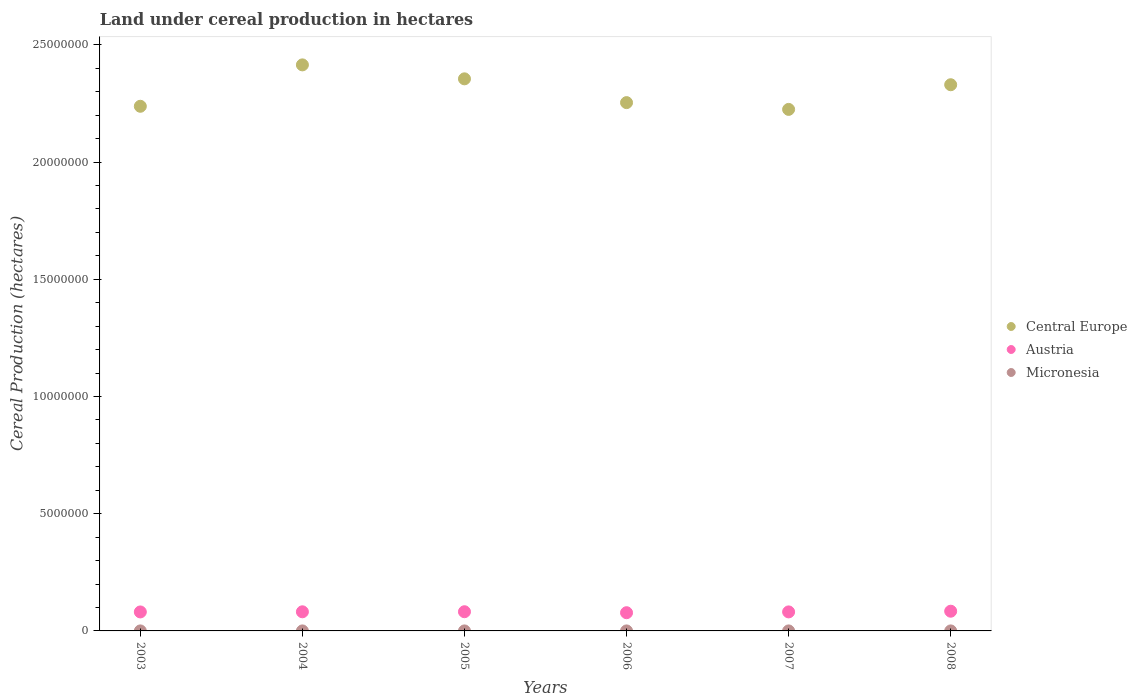What is the land under cereal production in Central Europe in 2007?
Provide a succinct answer. 2.22e+07. Across all years, what is the maximum land under cereal production in Austria?
Offer a terse response. 8.41e+05. Across all years, what is the minimum land under cereal production in Micronesia?
Offer a terse response. 140. In which year was the land under cereal production in Micronesia maximum?
Offer a terse response. 2004. In which year was the land under cereal production in Central Europe minimum?
Ensure brevity in your answer.  2007. What is the total land under cereal production in Austria in the graph?
Offer a terse response. 4.87e+06. What is the difference between the land under cereal production in Austria in 2004 and that in 2005?
Your answer should be compact. -2790. What is the difference between the land under cereal production in Micronesia in 2004 and the land under cereal production in Austria in 2007?
Make the answer very short. -8.11e+05. What is the average land under cereal production in Micronesia per year?
Offer a terse response. 149.67. In the year 2003, what is the difference between the land under cereal production in Central Europe and land under cereal production in Micronesia?
Your answer should be very brief. 2.24e+07. In how many years, is the land under cereal production in Micronesia greater than 12000000 hectares?
Provide a short and direct response. 0. What is the ratio of the land under cereal production in Austria in 2004 to that in 2006?
Keep it short and to the point. 1.05. Is the difference between the land under cereal production in Central Europe in 2003 and 2008 greater than the difference between the land under cereal production in Micronesia in 2003 and 2008?
Make the answer very short. No. What is the difference between the highest and the lowest land under cereal production in Austria?
Keep it short and to the point. 6.42e+04. Are the values on the major ticks of Y-axis written in scientific E-notation?
Provide a succinct answer. No. Does the graph contain any zero values?
Offer a very short reply. No. Does the graph contain grids?
Offer a very short reply. No. How many legend labels are there?
Your answer should be compact. 3. What is the title of the graph?
Your answer should be compact. Land under cereal production in hectares. Does "Kuwait" appear as one of the legend labels in the graph?
Ensure brevity in your answer.  No. What is the label or title of the X-axis?
Offer a very short reply. Years. What is the label or title of the Y-axis?
Offer a terse response. Cereal Production (hectares). What is the Cereal Production (hectares) of Central Europe in 2003?
Make the answer very short. 2.24e+07. What is the Cereal Production (hectares) in Austria in 2003?
Provide a succinct answer. 8.10e+05. What is the Cereal Production (hectares) in Micronesia in 2003?
Your answer should be very brief. 147. What is the Cereal Production (hectares) of Central Europe in 2004?
Your answer should be compact. 2.41e+07. What is the Cereal Production (hectares) of Austria in 2004?
Provide a succinct answer. 8.16e+05. What is the Cereal Production (hectares) of Micronesia in 2004?
Give a very brief answer. 158. What is the Cereal Production (hectares) in Central Europe in 2005?
Ensure brevity in your answer.  2.36e+07. What is the Cereal Production (hectares) of Austria in 2005?
Make the answer very short. 8.19e+05. What is the Cereal Production (hectares) of Micronesia in 2005?
Keep it short and to the point. 156. What is the Cereal Production (hectares) in Central Europe in 2006?
Provide a short and direct response. 2.25e+07. What is the Cereal Production (hectares) of Austria in 2006?
Provide a succinct answer. 7.77e+05. What is the Cereal Production (hectares) in Micronesia in 2006?
Provide a short and direct response. 154. What is the Cereal Production (hectares) of Central Europe in 2007?
Keep it short and to the point. 2.22e+07. What is the Cereal Production (hectares) in Austria in 2007?
Provide a short and direct response. 8.11e+05. What is the Cereal Production (hectares) in Micronesia in 2007?
Make the answer very short. 140. What is the Cereal Production (hectares) of Central Europe in 2008?
Provide a succinct answer. 2.33e+07. What is the Cereal Production (hectares) in Austria in 2008?
Your answer should be compact. 8.41e+05. What is the Cereal Production (hectares) in Micronesia in 2008?
Offer a very short reply. 143. Across all years, what is the maximum Cereal Production (hectares) in Central Europe?
Keep it short and to the point. 2.41e+07. Across all years, what is the maximum Cereal Production (hectares) in Austria?
Make the answer very short. 8.41e+05. Across all years, what is the maximum Cereal Production (hectares) in Micronesia?
Provide a short and direct response. 158. Across all years, what is the minimum Cereal Production (hectares) of Central Europe?
Give a very brief answer. 2.22e+07. Across all years, what is the minimum Cereal Production (hectares) in Austria?
Make the answer very short. 7.77e+05. Across all years, what is the minimum Cereal Production (hectares) in Micronesia?
Provide a succinct answer. 140. What is the total Cereal Production (hectares) of Central Europe in the graph?
Provide a short and direct response. 1.38e+08. What is the total Cereal Production (hectares) in Austria in the graph?
Ensure brevity in your answer.  4.87e+06. What is the total Cereal Production (hectares) in Micronesia in the graph?
Provide a succinct answer. 898. What is the difference between the Cereal Production (hectares) of Central Europe in 2003 and that in 2004?
Your response must be concise. -1.77e+06. What is the difference between the Cereal Production (hectares) in Austria in 2003 and that in 2004?
Keep it short and to the point. -5969. What is the difference between the Cereal Production (hectares) of Micronesia in 2003 and that in 2004?
Your answer should be very brief. -11. What is the difference between the Cereal Production (hectares) in Central Europe in 2003 and that in 2005?
Provide a succinct answer. -1.17e+06. What is the difference between the Cereal Production (hectares) of Austria in 2003 and that in 2005?
Give a very brief answer. -8759. What is the difference between the Cereal Production (hectares) in Micronesia in 2003 and that in 2005?
Keep it short and to the point. -9. What is the difference between the Cereal Production (hectares) in Central Europe in 2003 and that in 2006?
Your answer should be compact. -1.56e+05. What is the difference between the Cereal Production (hectares) of Austria in 2003 and that in 2006?
Keep it short and to the point. 3.30e+04. What is the difference between the Cereal Production (hectares) of Micronesia in 2003 and that in 2006?
Your answer should be compact. -7. What is the difference between the Cereal Production (hectares) of Central Europe in 2003 and that in 2007?
Your answer should be compact. 1.33e+05. What is the difference between the Cereal Production (hectares) in Austria in 2003 and that in 2007?
Give a very brief answer. -1349. What is the difference between the Cereal Production (hectares) of Central Europe in 2003 and that in 2008?
Your response must be concise. -9.19e+05. What is the difference between the Cereal Production (hectares) of Austria in 2003 and that in 2008?
Provide a short and direct response. -3.12e+04. What is the difference between the Cereal Production (hectares) in Central Europe in 2004 and that in 2005?
Provide a succinct answer. 5.96e+05. What is the difference between the Cereal Production (hectares) of Austria in 2004 and that in 2005?
Give a very brief answer. -2790. What is the difference between the Cereal Production (hectares) in Micronesia in 2004 and that in 2005?
Provide a succinct answer. 2. What is the difference between the Cereal Production (hectares) of Central Europe in 2004 and that in 2006?
Provide a succinct answer. 1.61e+06. What is the difference between the Cereal Production (hectares) in Austria in 2004 and that in 2006?
Make the answer very short. 3.90e+04. What is the difference between the Cereal Production (hectares) of Micronesia in 2004 and that in 2006?
Your answer should be very brief. 4. What is the difference between the Cereal Production (hectares) in Central Europe in 2004 and that in 2007?
Give a very brief answer. 1.90e+06. What is the difference between the Cereal Production (hectares) in Austria in 2004 and that in 2007?
Offer a terse response. 4620. What is the difference between the Cereal Production (hectares) of Central Europe in 2004 and that in 2008?
Give a very brief answer. 8.47e+05. What is the difference between the Cereal Production (hectares) of Austria in 2004 and that in 2008?
Give a very brief answer. -2.52e+04. What is the difference between the Cereal Production (hectares) of Micronesia in 2004 and that in 2008?
Your response must be concise. 15. What is the difference between the Cereal Production (hectares) in Central Europe in 2005 and that in 2006?
Keep it short and to the point. 1.01e+06. What is the difference between the Cereal Production (hectares) of Austria in 2005 and that in 2006?
Offer a very short reply. 4.18e+04. What is the difference between the Cereal Production (hectares) of Central Europe in 2005 and that in 2007?
Offer a terse response. 1.30e+06. What is the difference between the Cereal Production (hectares) of Austria in 2005 and that in 2007?
Your response must be concise. 7410. What is the difference between the Cereal Production (hectares) of Micronesia in 2005 and that in 2007?
Offer a very short reply. 16. What is the difference between the Cereal Production (hectares) in Central Europe in 2005 and that in 2008?
Provide a short and direct response. 2.52e+05. What is the difference between the Cereal Production (hectares) in Austria in 2005 and that in 2008?
Keep it short and to the point. -2.24e+04. What is the difference between the Cereal Production (hectares) in Central Europe in 2006 and that in 2007?
Offer a terse response. 2.89e+05. What is the difference between the Cereal Production (hectares) of Austria in 2006 and that in 2007?
Your response must be concise. -3.44e+04. What is the difference between the Cereal Production (hectares) of Central Europe in 2006 and that in 2008?
Ensure brevity in your answer.  -7.63e+05. What is the difference between the Cereal Production (hectares) in Austria in 2006 and that in 2008?
Keep it short and to the point. -6.42e+04. What is the difference between the Cereal Production (hectares) in Central Europe in 2007 and that in 2008?
Your answer should be compact. -1.05e+06. What is the difference between the Cereal Production (hectares) in Austria in 2007 and that in 2008?
Offer a terse response. -2.98e+04. What is the difference between the Cereal Production (hectares) in Micronesia in 2007 and that in 2008?
Offer a terse response. -3. What is the difference between the Cereal Production (hectares) of Central Europe in 2003 and the Cereal Production (hectares) of Austria in 2004?
Your answer should be very brief. 2.16e+07. What is the difference between the Cereal Production (hectares) of Central Europe in 2003 and the Cereal Production (hectares) of Micronesia in 2004?
Offer a terse response. 2.24e+07. What is the difference between the Cereal Production (hectares) in Austria in 2003 and the Cereal Production (hectares) in Micronesia in 2004?
Ensure brevity in your answer.  8.10e+05. What is the difference between the Cereal Production (hectares) in Central Europe in 2003 and the Cereal Production (hectares) in Austria in 2005?
Make the answer very short. 2.16e+07. What is the difference between the Cereal Production (hectares) of Central Europe in 2003 and the Cereal Production (hectares) of Micronesia in 2005?
Ensure brevity in your answer.  2.24e+07. What is the difference between the Cereal Production (hectares) in Austria in 2003 and the Cereal Production (hectares) in Micronesia in 2005?
Keep it short and to the point. 8.10e+05. What is the difference between the Cereal Production (hectares) in Central Europe in 2003 and the Cereal Production (hectares) in Austria in 2006?
Keep it short and to the point. 2.16e+07. What is the difference between the Cereal Production (hectares) of Central Europe in 2003 and the Cereal Production (hectares) of Micronesia in 2006?
Provide a short and direct response. 2.24e+07. What is the difference between the Cereal Production (hectares) of Austria in 2003 and the Cereal Production (hectares) of Micronesia in 2006?
Offer a very short reply. 8.10e+05. What is the difference between the Cereal Production (hectares) of Central Europe in 2003 and the Cereal Production (hectares) of Austria in 2007?
Ensure brevity in your answer.  2.16e+07. What is the difference between the Cereal Production (hectares) in Central Europe in 2003 and the Cereal Production (hectares) in Micronesia in 2007?
Your answer should be compact. 2.24e+07. What is the difference between the Cereal Production (hectares) in Austria in 2003 and the Cereal Production (hectares) in Micronesia in 2007?
Provide a succinct answer. 8.10e+05. What is the difference between the Cereal Production (hectares) of Central Europe in 2003 and the Cereal Production (hectares) of Austria in 2008?
Give a very brief answer. 2.15e+07. What is the difference between the Cereal Production (hectares) of Central Europe in 2003 and the Cereal Production (hectares) of Micronesia in 2008?
Provide a short and direct response. 2.24e+07. What is the difference between the Cereal Production (hectares) in Austria in 2003 and the Cereal Production (hectares) in Micronesia in 2008?
Ensure brevity in your answer.  8.10e+05. What is the difference between the Cereal Production (hectares) of Central Europe in 2004 and the Cereal Production (hectares) of Austria in 2005?
Ensure brevity in your answer.  2.33e+07. What is the difference between the Cereal Production (hectares) of Central Europe in 2004 and the Cereal Production (hectares) of Micronesia in 2005?
Offer a very short reply. 2.41e+07. What is the difference between the Cereal Production (hectares) of Austria in 2004 and the Cereal Production (hectares) of Micronesia in 2005?
Your response must be concise. 8.16e+05. What is the difference between the Cereal Production (hectares) of Central Europe in 2004 and the Cereal Production (hectares) of Austria in 2006?
Provide a succinct answer. 2.34e+07. What is the difference between the Cereal Production (hectares) in Central Europe in 2004 and the Cereal Production (hectares) in Micronesia in 2006?
Provide a succinct answer. 2.41e+07. What is the difference between the Cereal Production (hectares) of Austria in 2004 and the Cereal Production (hectares) of Micronesia in 2006?
Your response must be concise. 8.16e+05. What is the difference between the Cereal Production (hectares) in Central Europe in 2004 and the Cereal Production (hectares) in Austria in 2007?
Your response must be concise. 2.33e+07. What is the difference between the Cereal Production (hectares) in Central Europe in 2004 and the Cereal Production (hectares) in Micronesia in 2007?
Your response must be concise. 2.41e+07. What is the difference between the Cereal Production (hectares) of Austria in 2004 and the Cereal Production (hectares) of Micronesia in 2007?
Your response must be concise. 8.16e+05. What is the difference between the Cereal Production (hectares) in Central Europe in 2004 and the Cereal Production (hectares) in Austria in 2008?
Give a very brief answer. 2.33e+07. What is the difference between the Cereal Production (hectares) in Central Europe in 2004 and the Cereal Production (hectares) in Micronesia in 2008?
Give a very brief answer. 2.41e+07. What is the difference between the Cereal Production (hectares) in Austria in 2004 and the Cereal Production (hectares) in Micronesia in 2008?
Ensure brevity in your answer.  8.16e+05. What is the difference between the Cereal Production (hectares) in Central Europe in 2005 and the Cereal Production (hectares) in Austria in 2006?
Provide a short and direct response. 2.28e+07. What is the difference between the Cereal Production (hectares) in Central Europe in 2005 and the Cereal Production (hectares) in Micronesia in 2006?
Offer a very short reply. 2.36e+07. What is the difference between the Cereal Production (hectares) of Austria in 2005 and the Cereal Production (hectares) of Micronesia in 2006?
Your response must be concise. 8.18e+05. What is the difference between the Cereal Production (hectares) of Central Europe in 2005 and the Cereal Production (hectares) of Austria in 2007?
Offer a terse response. 2.27e+07. What is the difference between the Cereal Production (hectares) of Central Europe in 2005 and the Cereal Production (hectares) of Micronesia in 2007?
Your answer should be compact. 2.36e+07. What is the difference between the Cereal Production (hectares) of Austria in 2005 and the Cereal Production (hectares) of Micronesia in 2007?
Offer a very short reply. 8.18e+05. What is the difference between the Cereal Production (hectares) of Central Europe in 2005 and the Cereal Production (hectares) of Austria in 2008?
Offer a very short reply. 2.27e+07. What is the difference between the Cereal Production (hectares) of Central Europe in 2005 and the Cereal Production (hectares) of Micronesia in 2008?
Offer a very short reply. 2.36e+07. What is the difference between the Cereal Production (hectares) in Austria in 2005 and the Cereal Production (hectares) in Micronesia in 2008?
Provide a short and direct response. 8.18e+05. What is the difference between the Cereal Production (hectares) in Central Europe in 2006 and the Cereal Production (hectares) in Austria in 2007?
Offer a very short reply. 2.17e+07. What is the difference between the Cereal Production (hectares) in Central Europe in 2006 and the Cereal Production (hectares) in Micronesia in 2007?
Give a very brief answer. 2.25e+07. What is the difference between the Cereal Production (hectares) of Austria in 2006 and the Cereal Production (hectares) of Micronesia in 2007?
Your response must be concise. 7.77e+05. What is the difference between the Cereal Production (hectares) of Central Europe in 2006 and the Cereal Production (hectares) of Austria in 2008?
Give a very brief answer. 2.17e+07. What is the difference between the Cereal Production (hectares) in Central Europe in 2006 and the Cereal Production (hectares) in Micronesia in 2008?
Provide a short and direct response. 2.25e+07. What is the difference between the Cereal Production (hectares) in Austria in 2006 and the Cereal Production (hectares) in Micronesia in 2008?
Provide a short and direct response. 7.77e+05. What is the difference between the Cereal Production (hectares) in Central Europe in 2007 and the Cereal Production (hectares) in Austria in 2008?
Provide a short and direct response. 2.14e+07. What is the difference between the Cereal Production (hectares) of Central Europe in 2007 and the Cereal Production (hectares) of Micronesia in 2008?
Your response must be concise. 2.22e+07. What is the difference between the Cereal Production (hectares) of Austria in 2007 and the Cereal Production (hectares) of Micronesia in 2008?
Provide a succinct answer. 8.11e+05. What is the average Cereal Production (hectares) of Central Europe per year?
Keep it short and to the point. 2.30e+07. What is the average Cereal Production (hectares) of Austria per year?
Offer a very short reply. 8.12e+05. What is the average Cereal Production (hectares) of Micronesia per year?
Make the answer very short. 149.67. In the year 2003, what is the difference between the Cereal Production (hectares) in Central Europe and Cereal Production (hectares) in Austria?
Offer a terse response. 2.16e+07. In the year 2003, what is the difference between the Cereal Production (hectares) in Central Europe and Cereal Production (hectares) in Micronesia?
Offer a very short reply. 2.24e+07. In the year 2003, what is the difference between the Cereal Production (hectares) in Austria and Cereal Production (hectares) in Micronesia?
Keep it short and to the point. 8.10e+05. In the year 2004, what is the difference between the Cereal Production (hectares) in Central Europe and Cereal Production (hectares) in Austria?
Your answer should be compact. 2.33e+07. In the year 2004, what is the difference between the Cereal Production (hectares) of Central Europe and Cereal Production (hectares) of Micronesia?
Offer a terse response. 2.41e+07. In the year 2004, what is the difference between the Cereal Production (hectares) in Austria and Cereal Production (hectares) in Micronesia?
Your response must be concise. 8.16e+05. In the year 2005, what is the difference between the Cereal Production (hectares) in Central Europe and Cereal Production (hectares) in Austria?
Make the answer very short. 2.27e+07. In the year 2005, what is the difference between the Cereal Production (hectares) of Central Europe and Cereal Production (hectares) of Micronesia?
Make the answer very short. 2.36e+07. In the year 2005, what is the difference between the Cereal Production (hectares) in Austria and Cereal Production (hectares) in Micronesia?
Your response must be concise. 8.18e+05. In the year 2006, what is the difference between the Cereal Production (hectares) in Central Europe and Cereal Production (hectares) in Austria?
Keep it short and to the point. 2.18e+07. In the year 2006, what is the difference between the Cereal Production (hectares) in Central Europe and Cereal Production (hectares) in Micronesia?
Offer a terse response. 2.25e+07. In the year 2006, what is the difference between the Cereal Production (hectares) in Austria and Cereal Production (hectares) in Micronesia?
Offer a very short reply. 7.77e+05. In the year 2007, what is the difference between the Cereal Production (hectares) in Central Europe and Cereal Production (hectares) in Austria?
Make the answer very short. 2.14e+07. In the year 2007, what is the difference between the Cereal Production (hectares) in Central Europe and Cereal Production (hectares) in Micronesia?
Offer a very short reply. 2.22e+07. In the year 2007, what is the difference between the Cereal Production (hectares) of Austria and Cereal Production (hectares) of Micronesia?
Keep it short and to the point. 8.11e+05. In the year 2008, what is the difference between the Cereal Production (hectares) of Central Europe and Cereal Production (hectares) of Austria?
Ensure brevity in your answer.  2.25e+07. In the year 2008, what is the difference between the Cereal Production (hectares) in Central Europe and Cereal Production (hectares) in Micronesia?
Ensure brevity in your answer.  2.33e+07. In the year 2008, what is the difference between the Cereal Production (hectares) of Austria and Cereal Production (hectares) of Micronesia?
Offer a very short reply. 8.41e+05. What is the ratio of the Cereal Production (hectares) of Central Europe in 2003 to that in 2004?
Your answer should be compact. 0.93. What is the ratio of the Cereal Production (hectares) in Micronesia in 2003 to that in 2004?
Provide a succinct answer. 0.93. What is the ratio of the Cereal Production (hectares) in Central Europe in 2003 to that in 2005?
Provide a succinct answer. 0.95. What is the ratio of the Cereal Production (hectares) in Austria in 2003 to that in 2005?
Keep it short and to the point. 0.99. What is the ratio of the Cereal Production (hectares) in Micronesia in 2003 to that in 2005?
Offer a terse response. 0.94. What is the ratio of the Cereal Production (hectares) of Central Europe in 2003 to that in 2006?
Offer a very short reply. 0.99. What is the ratio of the Cereal Production (hectares) of Austria in 2003 to that in 2006?
Offer a terse response. 1.04. What is the ratio of the Cereal Production (hectares) in Micronesia in 2003 to that in 2006?
Your answer should be compact. 0.95. What is the ratio of the Cereal Production (hectares) of Central Europe in 2003 to that in 2007?
Offer a very short reply. 1.01. What is the ratio of the Cereal Production (hectares) in Micronesia in 2003 to that in 2007?
Your answer should be compact. 1.05. What is the ratio of the Cereal Production (hectares) in Central Europe in 2003 to that in 2008?
Give a very brief answer. 0.96. What is the ratio of the Cereal Production (hectares) of Austria in 2003 to that in 2008?
Offer a very short reply. 0.96. What is the ratio of the Cereal Production (hectares) of Micronesia in 2003 to that in 2008?
Make the answer very short. 1.03. What is the ratio of the Cereal Production (hectares) of Central Europe in 2004 to that in 2005?
Offer a very short reply. 1.03. What is the ratio of the Cereal Production (hectares) of Micronesia in 2004 to that in 2005?
Offer a very short reply. 1.01. What is the ratio of the Cereal Production (hectares) in Central Europe in 2004 to that in 2006?
Make the answer very short. 1.07. What is the ratio of the Cereal Production (hectares) of Austria in 2004 to that in 2006?
Your answer should be compact. 1.05. What is the ratio of the Cereal Production (hectares) of Micronesia in 2004 to that in 2006?
Give a very brief answer. 1.03. What is the ratio of the Cereal Production (hectares) of Central Europe in 2004 to that in 2007?
Your answer should be very brief. 1.09. What is the ratio of the Cereal Production (hectares) in Austria in 2004 to that in 2007?
Ensure brevity in your answer.  1.01. What is the ratio of the Cereal Production (hectares) in Micronesia in 2004 to that in 2007?
Give a very brief answer. 1.13. What is the ratio of the Cereal Production (hectares) of Central Europe in 2004 to that in 2008?
Your answer should be compact. 1.04. What is the ratio of the Cereal Production (hectares) of Austria in 2004 to that in 2008?
Give a very brief answer. 0.97. What is the ratio of the Cereal Production (hectares) in Micronesia in 2004 to that in 2008?
Provide a short and direct response. 1.1. What is the ratio of the Cereal Production (hectares) in Central Europe in 2005 to that in 2006?
Your answer should be compact. 1.04. What is the ratio of the Cereal Production (hectares) of Austria in 2005 to that in 2006?
Your answer should be compact. 1.05. What is the ratio of the Cereal Production (hectares) of Central Europe in 2005 to that in 2007?
Keep it short and to the point. 1.06. What is the ratio of the Cereal Production (hectares) in Austria in 2005 to that in 2007?
Provide a succinct answer. 1.01. What is the ratio of the Cereal Production (hectares) in Micronesia in 2005 to that in 2007?
Provide a short and direct response. 1.11. What is the ratio of the Cereal Production (hectares) in Central Europe in 2005 to that in 2008?
Keep it short and to the point. 1.01. What is the ratio of the Cereal Production (hectares) of Austria in 2005 to that in 2008?
Give a very brief answer. 0.97. What is the ratio of the Cereal Production (hectares) in Micronesia in 2005 to that in 2008?
Keep it short and to the point. 1.09. What is the ratio of the Cereal Production (hectares) of Central Europe in 2006 to that in 2007?
Offer a very short reply. 1.01. What is the ratio of the Cereal Production (hectares) of Austria in 2006 to that in 2007?
Your answer should be very brief. 0.96. What is the ratio of the Cereal Production (hectares) in Central Europe in 2006 to that in 2008?
Give a very brief answer. 0.97. What is the ratio of the Cereal Production (hectares) of Austria in 2006 to that in 2008?
Your answer should be compact. 0.92. What is the ratio of the Cereal Production (hectares) of Micronesia in 2006 to that in 2008?
Offer a terse response. 1.08. What is the ratio of the Cereal Production (hectares) in Central Europe in 2007 to that in 2008?
Your response must be concise. 0.95. What is the ratio of the Cereal Production (hectares) in Austria in 2007 to that in 2008?
Ensure brevity in your answer.  0.96. What is the ratio of the Cereal Production (hectares) of Micronesia in 2007 to that in 2008?
Provide a short and direct response. 0.98. What is the difference between the highest and the second highest Cereal Production (hectares) of Central Europe?
Make the answer very short. 5.96e+05. What is the difference between the highest and the second highest Cereal Production (hectares) of Austria?
Keep it short and to the point. 2.24e+04. What is the difference between the highest and the second highest Cereal Production (hectares) in Micronesia?
Ensure brevity in your answer.  2. What is the difference between the highest and the lowest Cereal Production (hectares) of Central Europe?
Offer a very short reply. 1.90e+06. What is the difference between the highest and the lowest Cereal Production (hectares) of Austria?
Give a very brief answer. 6.42e+04. What is the difference between the highest and the lowest Cereal Production (hectares) of Micronesia?
Offer a terse response. 18. 